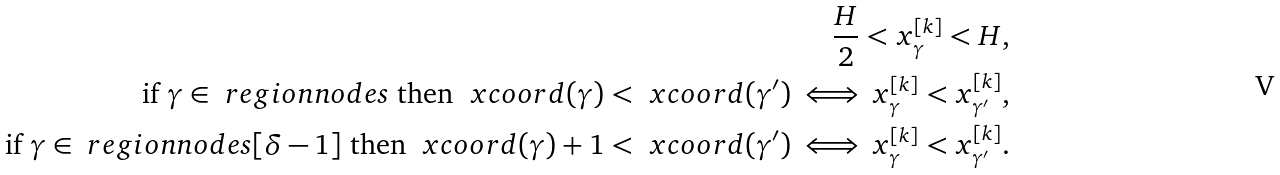Convert formula to latex. <formula><loc_0><loc_0><loc_500><loc_500>\frac { H } { 2 } < x ^ { [ k ] } _ { \gamma } < H , \\ \text {if } \gamma \in \ r e g i o n n o d e s \text { then } \ x c o o r d ( \gamma ) < \ x c o o r d ( \gamma ^ { \prime } ) \iff x ^ { [ k ] } _ { \gamma } < x ^ { [ k ] } _ { \gamma ^ { \prime } } , \\ \text {if } \gamma \in \ r e g i o n n o d e s [ \delta - 1 ] \text { then } \ x c o o r d ( \gamma ) + 1 < \ x c o o r d ( \gamma ^ { \prime } ) \iff x ^ { [ k ] } _ { \gamma } < x ^ { [ k ] } _ { \gamma ^ { \prime } } .</formula> 